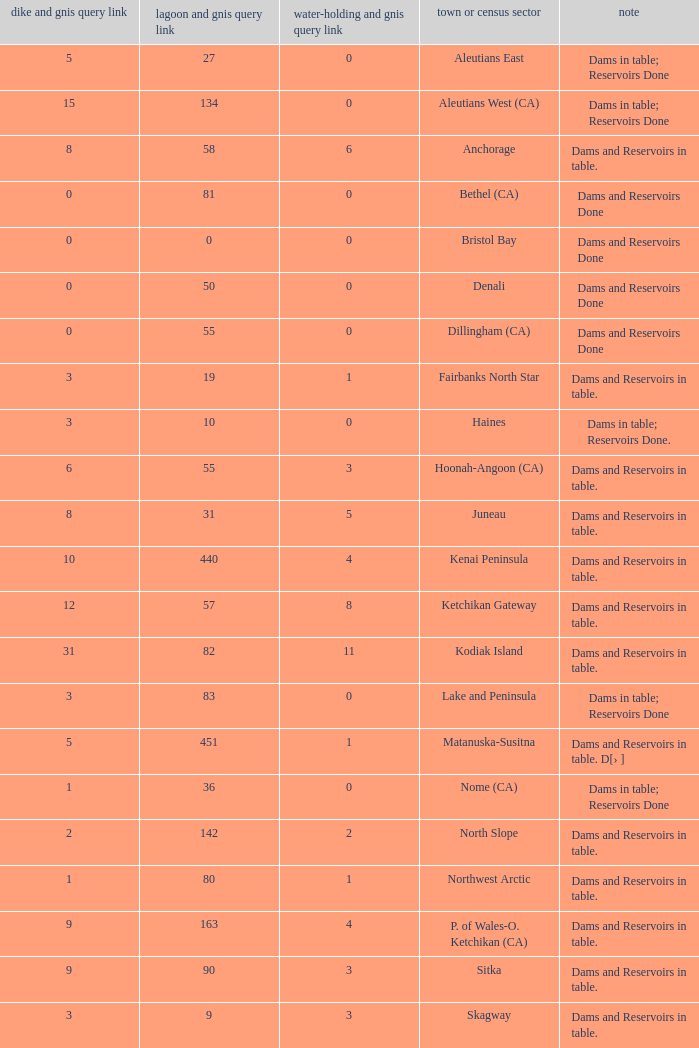Name the minimum number of reservoir for gnis query link where numbers lake gnis query link being 60 5.0. 